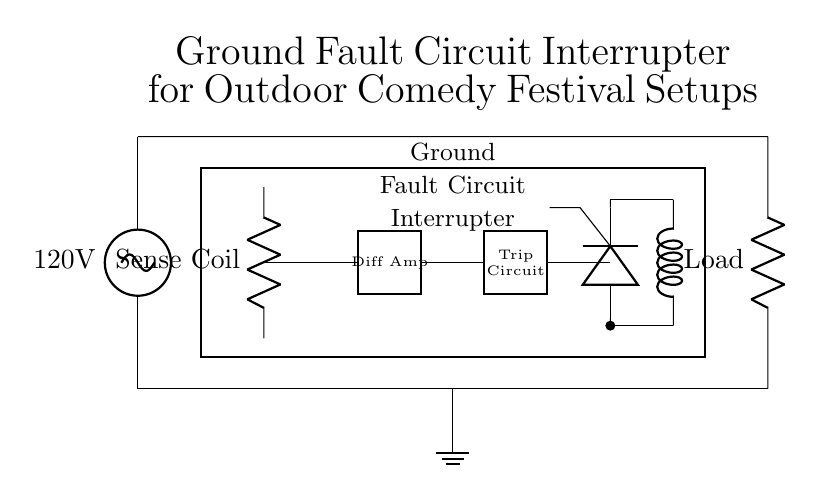What component is used to interrupt the circuit? The component that interrupts the circuit is the Ground Fault Circuit Interrupter, indicated as a rectangle labeled in the diagram.
Answer: Ground Fault Circuit Interrupter What is the voltage rating of the power source? The power source is labeled as having a voltage of 120 volts, which is directly indicated in the circuit diagram.
Answer: 120 volts What is the purpose of the 'Sense Coil'? The 'Sense Coil' is used to detect ground faults by sensing imbalance between the supply and return currents. Its functionality is crucial for triggering the GFCI.
Answer: Detect ground faults Where is the ground connection located? The ground connection is represented by a ground symbol located at the bottom center of the diagram, showing where the circuit connects to the earth.
Answer: Bottom center What type of device is represented by the rectangle labeled 'Trip Circuit'? The 'Trip Circuit' is a control mechanism within the GFCI that activates the interrupting action when a ground fault is detected, ensuring safety.
Answer: Control mechanism How many major components are labeled in the diagram? The diagram has five major components clearly labeled: Ground Fault Circuit Interrupter, Load, Sense Coil, Trip Circuit, and SCR. Counting these gives the total.
Answer: Five What role does the SCR play in this circuit? The SCR (Silicon Controlled Rectifier) is used as a switch that allows the circuit to trip by shorting the load during a fault condition, providing safety against shocks.
Answer: Acts as a switch 